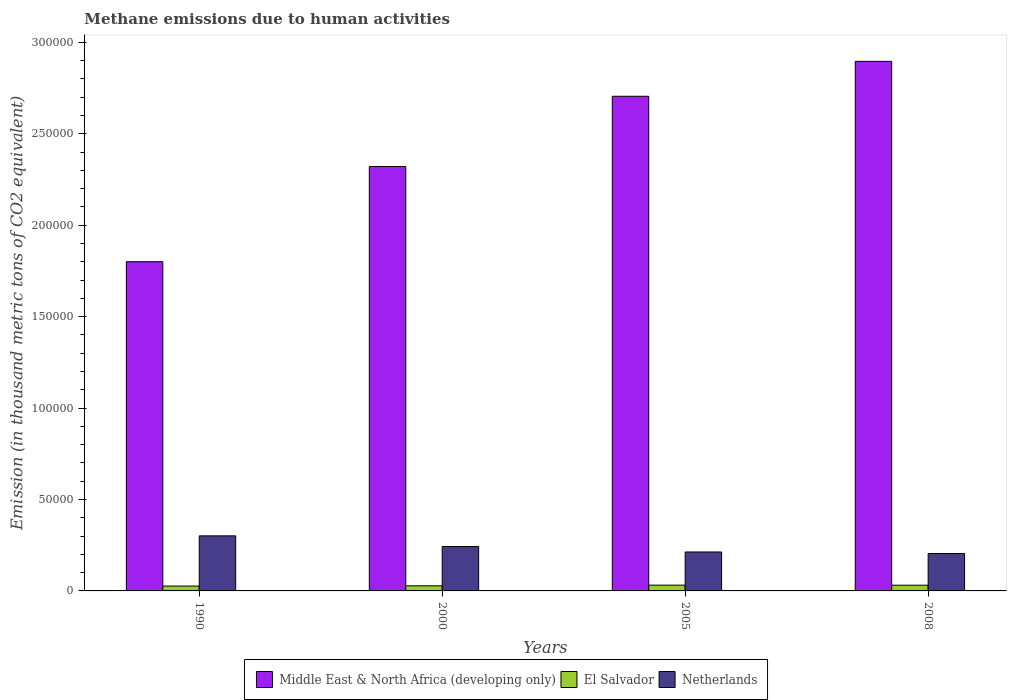How many groups of bars are there?
Make the answer very short. 4. Are the number of bars per tick equal to the number of legend labels?
Provide a short and direct response. Yes. Are the number of bars on each tick of the X-axis equal?
Provide a short and direct response. Yes. How many bars are there on the 1st tick from the left?
Give a very brief answer. 3. What is the label of the 2nd group of bars from the left?
Provide a short and direct response. 2000. What is the amount of methane emitted in El Salvador in 2008?
Your answer should be compact. 3127.7. Across all years, what is the maximum amount of methane emitted in Netherlands?
Make the answer very short. 3.01e+04. Across all years, what is the minimum amount of methane emitted in El Salvador?
Ensure brevity in your answer.  2672.9. What is the total amount of methane emitted in Netherlands in the graph?
Provide a short and direct response. 9.62e+04. What is the difference between the amount of methane emitted in El Salvador in 1990 and that in 2005?
Make the answer very short. -479.9. What is the difference between the amount of methane emitted in El Salvador in 2008 and the amount of methane emitted in Netherlands in 1990?
Your response must be concise. -2.70e+04. What is the average amount of methane emitted in Netherlands per year?
Offer a terse response. 2.40e+04. In the year 2005, what is the difference between the amount of methane emitted in El Salvador and amount of methane emitted in Netherlands?
Make the answer very short. -1.81e+04. What is the ratio of the amount of methane emitted in Netherlands in 2000 to that in 2005?
Your response must be concise. 1.14. Is the amount of methane emitted in El Salvador in 2000 less than that in 2005?
Give a very brief answer. Yes. Is the difference between the amount of methane emitted in El Salvador in 2000 and 2005 greater than the difference between the amount of methane emitted in Netherlands in 2000 and 2005?
Your answer should be very brief. No. What is the difference between the highest and the second highest amount of methane emitted in El Salvador?
Make the answer very short. 25.1. What is the difference between the highest and the lowest amount of methane emitted in Middle East & North Africa (developing only)?
Keep it short and to the point. 1.10e+05. In how many years, is the amount of methane emitted in Netherlands greater than the average amount of methane emitted in Netherlands taken over all years?
Provide a succinct answer. 2. What does the 1st bar from the left in 1990 represents?
Your response must be concise. Middle East & North Africa (developing only). How many bars are there?
Your answer should be compact. 12. Are all the bars in the graph horizontal?
Make the answer very short. No. How many years are there in the graph?
Keep it short and to the point. 4. What is the difference between two consecutive major ticks on the Y-axis?
Keep it short and to the point. 5.00e+04. Does the graph contain grids?
Your response must be concise. No. Where does the legend appear in the graph?
Give a very brief answer. Bottom center. How many legend labels are there?
Your answer should be very brief. 3. How are the legend labels stacked?
Give a very brief answer. Horizontal. What is the title of the graph?
Provide a short and direct response. Methane emissions due to human activities. Does "Ghana" appear as one of the legend labels in the graph?
Offer a very short reply. No. What is the label or title of the Y-axis?
Your answer should be compact. Emission (in thousand metric tons of CO2 equivalent). What is the Emission (in thousand metric tons of CO2 equivalent) of Middle East & North Africa (developing only) in 1990?
Your answer should be compact. 1.80e+05. What is the Emission (in thousand metric tons of CO2 equivalent) in El Salvador in 1990?
Offer a very short reply. 2672.9. What is the Emission (in thousand metric tons of CO2 equivalent) in Netherlands in 1990?
Make the answer very short. 3.01e+04. What is the Emission (in thousand metric tons of CO2 equivalent) in Middle East & North Africa (developing only) in 2000?
Your response must be concise. 2.32e+05. What is the Emission (in thousand metric tons of CO2 equivalent) in El Salvador in 2000?
Offer a terse response. 2798.1. What is the Emission (in thousand metric tons of CO2 equivalent) of Netherlands in 2000?
Your answer should be very brief. 2.43e+04. What is the Emission (in thousand metric tons of CO2 equivalent) of Middle East & North Africa (developing only) in 2005?
Provide a short and direct response. 2.71e+05. What is the Emission (in thousand metric tons of CO2 equivalent) of El Salvador in 2005?
Your answer should be very brief. 3152.8. What is the Emission (in thousand metric tons of CO2 equivalent) in Netherlands in 2005?
Keep it short and to the point. 2.13e+04. What is the Emission (in thousand metric tons of CO2 equivalent) in Middle East & North Africa (developing only) in 2008?
Your response must be concise. 2.90e+05. What is the Emission (in thousand metric tons of CO2 equivalent) of El Salvador in 2008?
Make the answer very short. 3127.7. What is the Emission (in thousand metric tons of CO2 equivalent) in Netherlands in 2008?
Your answer should be compact. 2.05e+04. Across all years, what is the maximum Emission (in thousand metric tons of CO2 equivalent) of Middle East & North Africa (developing only)?
Your answer should be very brief. 2.90e+05. Across all years, what is the maximum Emission (in thousand metric tons of CO2 equivalent) in El Salvador?
Keep it short and to the point. 3152.8. Across all years, what is the maximum Emission (in thousand metric tons of CO2 equivalent) in Netherlands?
Your response must be concise. 3.01e+04. Across all years, what is the minimum Emission (in thousand metric tons of CO2 equivalent) of Middle East & North Africa (developing only)?
Provide a short and direct response. 1.80e+05. Across all years, what is the minimum Emission (in thousand metric tons of CO2 equivalent) of El Salvador?
Provide a short and direct response. 2672.9. Across all years, what is the minimum Emission (in thousand metric tons of CO2 equivalent) in Netherlands?
Make the answer very short. 2.05e+04. What is the total Emission (in thousand metric tons of CO2 equivalent) of Middle East & North Africa (developing only) in the graph?
Offer a very short reply. 9.72e+05. What is the total Emission (in thousand metric tons of CO2 equivalent) in El Salvador in the graph?
Your answer should be very brief. 1.18e+04. What is the total Emission (in thousand metric tons of CO2 equivalent) in Netherlands in the graph?
Make the answer very short. 9.62e+04. What is the difference between the Emission (in thousand metric tons of CO2 equivalent) in Middle East & North Africa (developing only) in 1990 and that in 2000?
Your answer should be compact. -5.20e+04. What is the difference between the Emission (in thousand metric tons of CO2 equivalent) in El Salvador in 1990 and that in 2000?
Provide a succinct answer. -125.2. What is the difference between the Emission (in thousand metric tons of CO2 equivalent) in Netherlands in 1990 and that in 2000?
Provide a short and direct response. 5828.3. What is the difference between the Emission (in thousand metric tons of CO2 equivalent) of Middle East & North Africa (developing only) in 1990 and that in 2005?
Your answer should be compact. -9.05e+04. What is the difference between the Emission (in thousand metric tons of CO2 equivalent) of El Salvador in 1990 and that in 2005?
Offer a terse response. -479.9. What is the difference between the Emission (in thousand metric tons of CO2 equivalent) in Netherlands in 1990 and that in 2005?
Your answer should be compact. 8818.6. What is the difference between the Emission (in thousand metric tons of CO2 equivalent) of Middle East & North Africa (developing only) in 1990 and that in 2008?
Your answer should be very brief. -1.10e+05. What is the difference between the Emission (in thousand metric tons of CO2 equivalent) in El Salvador in 1990 and that in 2008?
Your response must be concise. -454.8. What is the difference between the Emission (in thousand metric tons of CO2 equivalent) of Netherlands in 1990 and that in 2008?
Make the answer very short. 9650.1. What is the difference between the Emission (in thousand metric tons of CO2 equivalent) of Middle East & North Africa (developing only) in 2000 and that in 2005?
Offer a very short reply. -3.84e+04. What is the difference between the Emission (in thousand metric tons of CO2 equivalent) of El Salvador in 2000 and that in 2005?
Your response must be concise. -354.7. What is the difference between the Emission (in thousand metric tons of CO2 equivalent) of Netherlands in 2000 and that in 2005?
Keep it short and to the point. 2990.3. What is the difference between the Emission (in thousand metric tons of CO2 equivalent) of Middle East & North Africa (developing only) in 2000 and that in 2008?
Your answer should be compact. -5.75e+04. What is the difference between the Emission (in thousand metric tons of CO2 equivalent) of El Salvador in 2000 and that in 2008?
Give a very brief answer. -329.6. What is the difference between the Emission (in thousand metric tons of CO2 equivalent) in Netherlands in 2000 and that in 2008?
Provide a succinct answer. 3821.8. What is the difference between the Emission (in thousand metric tons of CO2 equivalent) of Middle East & North Africa (developing only) in 2005 and that in 2008?
Give a very brief answer. -1.91e+04. What is the difference between the Emission (in thousand metric tons of CO2 equivalent) in El Salvador in 2005 and that in 2008?
Your response must be concise. 25.1. What is the difference between the Emission (in thousand metric tons of CO2 equivalent) of Netherlands in 2005 and that in 2008?
Provide a succinct answer. 831.5. What is the difference between the Emission (in thousand metric tons of CO2 equivalent) of Middle East & North Africa (developing only) in 1990 and the Emission (in thousand metric tons of CO2 equivalent) of El Salvador in 2000?
Provide a short and direct response. 1.77e+05. What is the difference between the Emission (in thousand metric tons of CO2 equivalent) in Middle East & North Africa (developing only) in 1990 and the Emission (in thousand metric tons of CO2 equivalent) in Netherlands in 2000?
Keep it short and to the point. 1.56e+05. What is the difference between the Emission (in thousand metric tons of CO2 equivalent) in El Salvador in 1990 and the Emission (in thousand metric tons of CO2 equivalent) in Netherlands in 2000?
Provide a succinct answer. -2.16e+04. What is the difference between the Emission (in thousand metric tons of CO2 equivalent) of Middle East & North Africa (developing only) in 1990 and the Emission (in thousand metric tons of CO2 equivalent) of El Salvador in 2005?
Your response must be concise. 1.77e+05. What is the difference between the Emission (in thousand metric tons of CO2 equivalent) of Middle East & North Africa (developing only) in 1990 and the Emission (in thousand metric tons of CO2 equivalent) of Netherlands in 2005?
Provide a short and direct response. 1.59e+05. What is the difference between the Emission (in thousand metric tons of CO2 equivalent) of El Salvador in 1990 and the Emission (in thousand metric tons of CO2 equivalent) of Netherlands in 2005?
Make the answer very short. -1.86e+04. What is the difference between the Emission (in thousand metric tons of CO2 equivalent) in Middle East & North Africa (developing only) in 1990 and the Emission (in thousand metric tons of CO2 equivalent) in El Salvador in 2008?
Make the answer very short. 1.77e+05. What is the difference between the Emission (in thousand metric tons of CO2 equivalent) of Middle East & North Africa (developing only) in 1990 and the Emission (in thousand metric tons of CO2 equivalent) of Netherlands in 2008?
Make the answer very short. 1.60e+05. What is the difference between the Emission (in thousand metric tons of CO2 equivalent) of El Salvador in 1990 and the Emission (in thousand metric tons of CO2 equivalent) of Netherlands in 2008?
Your response must be concise. -1.78e+04. What is the difference between the Emission (in thousand metric tons of CO2 equivalent) in Middle East & North Africa (developing only) in 2000 and the Emission (in thousand metric tons of CO2 equivalent) in El Salvador in 2005?
Provide a short and direct response. 2.29e+05. What is the difference between the Emission (in thousand metric tons of CO2 equivalent) in Middle East & North Africa (developing only) in 2000 and the Emission (in thousand metric tons of CO2 equivalent) in Netherlands in 2005?
Ensure brevity in your answer.  2.11e+05. What is the difference between the Emission (in thousand metric tons of CO2 equivalent) of El Salvador in 2000 and the Emission (in thousand metric tons of CO2 equivalent) of Netherlands in 2005?
Your answer should be compact. -1.85e+04. What is the difference between the Emission (in thousand metric tons of CO2 equivalent) in Middle East & North Africa (developing only) in 2000 and the Emission (in thousand metric tons of CO2 equivalent) in El Salvador in 2008?
Provide a succinct answer. 2.29e+05. What is the difference between the Emission (in thousand metric tons of CO2 equivalent) in Middle East & North Africa (developing only) in 2000 and the Emission (in thousand metric tons of CO2 equivalent) in Netherlands in 2008?
Your response must be concise. 2.12e+05. What is the difference between the Emission (in thousand metric tons of CO2 equivalent) in El Salvador in 2000 and the Emission (in thousand metric tons of CO2 equivalent) in Netherlands in 2008?
Give a very brief answer. -1.77e+04. What is the difference between the Emission (in thousand metric tons of CO2 equivalent) in Middle East & North Africa (developing only) in 2005 and the Emission (in thousand metric tons of CO2 equivalent) in El Salvador in 2008?
Your answer should be very brief. 2.67e+05. What is the difference between the Emission (in thousand metric tons of CO2 equivalent) of Middle East & North Africa (developing only) in 2005 and the Emission (in thousand metric tons of CO2 equivalent) of Netherlands in 2008?
Offer a terse response. 2.50e+05. What is the difference between the Emission (in thousand metric tons of CO2 equivalent) of El Salvador in 2005 and the Emission (in thousand metric tons of CO2 equivalent) of Netherlands in 2008?
Offer a terse response. -1.73e+04. What is the average Emission (in thousand metric tons of CO2 equivalent) of Middle East & North Africa (developing only) per year?
Keep it short and to the point. 2.43e+05. What is the average Emission (in thousand metric tons of CO2 equivalent) in El Salvador per year?
Offer a terse response. 2937.88. What is the average Emission (in thousand metric tons of CO2 equivalent) of Netherlands per year?
Ensure brevity in your answer.  2.40e+04. In the year 1990, what is the difference between the Emission (in thousand metric tons of CO2 equivalent) of Middle East & North Africa (developing only) and Emission (in thousand metric tons of CO2 equivalent) of El Salvador?
Your answer should be compact. 1.77e+05. In the year 1990, what is the difference between the Emission (in thousand metric tons of CO2 equivalent) in Middle East & North Africa (developing only) and Emission (in thousand metric tons of CO2 equivalent) in Netherlands?
Provide a short and direct response. 1.50e+05. In the year 1990, what is the difference between the Emission (in thousand metric tons of CO2 equivalent) of El Salvador and Emission (in thousand metric tons of CO2 equivalent) of Netherlands?
Keep it short and to the point. -2.74e+04. In the year 2000, what is the difference between the Emission (in thousand metric tons of CO2 equivalent) of Middle East & North Africa (developing only) and Emission (in thousand metric tons of CO2 equivalent) of El Salvador?
Offer a terse response. 2.29e+05. In the year 2000, what is the difference between the Emission (in thousand metric tons of CO2 equivalent) of Middle East & North Africa (developing only) and Emission (in thousand metric tons of CO2 equivalent) of Netherlands?
Provide a short and direct response. 2.08e+05. In the year 2000, what is the difference between the Emission (in thousand metric tons of CO2 equivalent) of El Salvador and Emission (in thousand metric tons of CO2 equivalent) of Netherlands?
Keep it short and to the point. -2.15e+04. In the year 2005, what is the difference between the Emission (in thousand metric tons of CO2 equivalent) in Middle East & North Africa (developing only) and Emission (in thousand metric tons of CO2 equivalent) in El Salvador?
Provide a succinct answer. 2.67e+05. In the year 2005, what is the difference between the Emission (in thousand metric tons of CO2 equivalent) of Middle East & North Africa (developing only) and Emission (in thousand metric tons of CO2 equivalent) of Netherlands?
Your answer should be very brief. 2.49e+05. In the year 2005, what is the difference between the Emission (in thousand metric tons of CO2 equivalent) in El Salvador and Emission (in thousand metric tons of CO2 equivalent) in Netherlands?
Make the answer very short. -1.81e+04. In the year 2008, what is the difference between the Emission (in thousand metric tons of CO2 equivalent) in Middle East & North Africa (developing only) and Emission (in thousand metric tons of CO2 equivalent) in El Salvador?
Offer a very short reply. 2.86e+05. In the year 2008, what is the difference between the Emission (in thousand metric tons of CO2 equivalent) in Middle East & North Africa (developing only) and Emission (in thousand metric tons of CO2 equivalent) in Netherlands?
Provide a short and direct response. 2.69e+05. In the year 2008, what is the difference between the Emission (in thousand metric tons of CO2 equivalent) in El Salvador and Emission (in thousand metric tons of CO2 equivalent) in Netherlands?
Make the answer very short. -1.73e+04. What is the ratio of the Emission (in thousand metric tons of CO2 equivalent) of Middle East & North Africa (developing only) in 1990 to that in 2000?
Make the answer very short. 0.78. What is the ratio of the Emission (in thousand metric tons of CO2 equivalent) of El Salvador in 1990 to that in 2000?
Provide a succinct answer. 0.96. What is the ratio of the Emission (in thousand metric tons of CO2 equivalent) of Netherlands in 1990 to that in 2000?
Offer a terse response. 1.24. What is the ratio of the Emission (in thousand metric tons of CO2 equivalent) of Middle East & North Africa (developing only) in 1990 to that in 2005?
Your response must be concise. 0.67. What is the ratio of the Emission (in thousand metric tons of CO2 equivalent) of El Salvador in 1990 to that in 2005?
Give a very brief answer. 0.85. What is the ratio of the Emission (in thousand metric tons of CO2 equivalent) in Netherlands in 1990 to that in 2005?
Give a very brief answer. 1.41. What is the ratio of the Emission (in thousand metric tons of CO2 equivalent) of Middle East & North Africa (developing only) in 1990 to that in 2008?
Provide a short and direct response. 0.62. What is the ratio of the Emission (in thousand metric tons of CO2 equivalent) of El Salvador in 1990 to that in 2008?
Offer a very short reply. 0.85. What is the ratio of the Emission (in thousand metric tons of CO2 equivalent) of Netherlands in 1990 to that in 2008?
Offer a terse response. 1.47. What is the ratio of the Emission (in thousand metric tons of CO2 equivalent) of Middle East & North Africa (developing only) in 2000 to that in 2005?
Your answer should be very brief. 0.86. What is the ratio of the Emission (in thousand metric tons of CO2 equivalent) of El Salvador in 2000 to that in 2005?
Your answer should be compact. 0.89. What is the ratio of the Emission (in thousand metric tons of CO2 equivalent) in Netherlands in 2000 to that in 2005?
Your response must be concise. 1.14. What is the ratio of the Emission (in thousand metric tons of CO2 equivalent) in Middle East & North Africa (developing only) in 2000 to that in 2008?
Give a very brief answer. 0.8. What is the ratio of the Emission (in thousand metric tons of CO2 equivalent) in El Salvador in 2000 to that in 2008?
Your response must be concise. 0.89. What is the ratio of the Emission (in thousand metric tons of CO2 equivalent) in Netherlands in 2000 to that in 2008?
Keep it short and to the point. 1.19. What is the ratio of the Emission (in thousand metric tons of CO2 equivalent) of Middle East & North Africa (developing only) in 2005 to that in 2008?
Keep it short and to the point. 0.93. What is the ratio of the Emission (in thousand metric tons of CO2 equivalent) of Netherlands in 2005 to that in 2008?
Your answer should be compact. 1.04. What is the difference between the highest and the second highest Emission (in thousand metric tons of CO2 equivalent) in Middle East & North Africa (developing only)?
Offer a terse response. 1.91e+04. What is the difference between the highest and the second highest Emission (in thousand metric tons of CO2 equivalent) in El Salvador?
Offer a terse response. 25.1. What is the difference between the highest and the second highest Emission (in thousand metric tons of CO2 equivalent) of Netherlands?
Your response must be concise. 5828.3. What is the difference between the highest and the lowest Emission (in thousand metric tons of CO2 equivalent) of Middle East & North Africa (developing only)?
Provide a succinct answer. 1.10e+05. What is the difference between the highest and the lowest Emission (in thousand metric tons of CO2 equivalent) of El Salvador?
Ensure brevity in your answer.  479.9. What is the difference between the highest and the lowest Emission (in thousand metric tons of CO2 equivalent) of Netherlands?
Provide a succinct answer. 9650.1. 